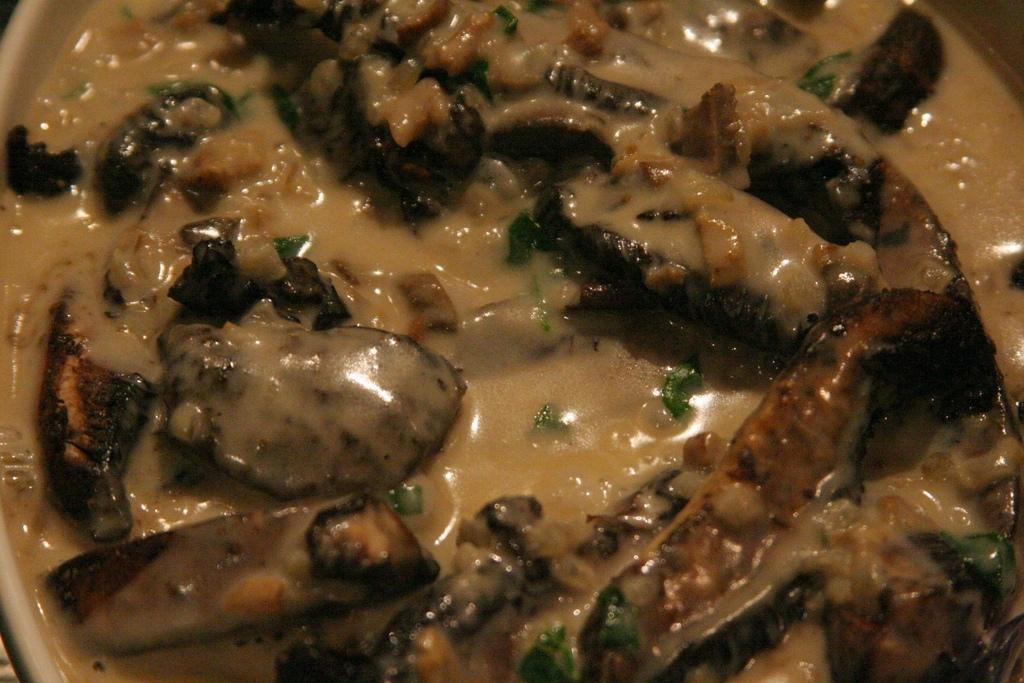What is in the bowl that is visible in the image? There is food in a bowl in the image. What type of food is in the bowl? The food in the bowl is a salad, as indicated by the presence of mint leaves. What word is written on the loaf of bread in the image? There is no loaf of bread present in the image, so it is not possible to answer that question. 